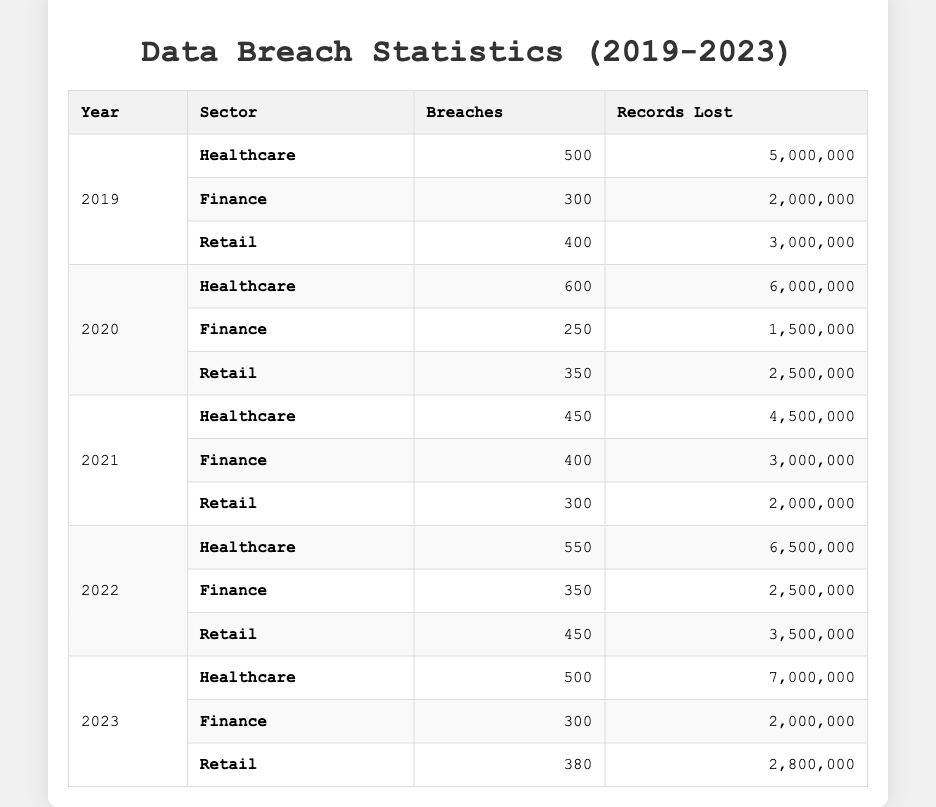What sector had the highest number of data breaches in 2020? In 2020, the Healthcare sector had 600 breaches, while Finance had 250 and Retail had 350. Therefore, Healthcare had the highest number of breaches.
Answer: Healthcare What is the total number of records lost in the Finance sector from 2019 to 2023? The records lost in Finance are: 2,000,000 (2019) + 1,500,000 (2020) + 3,000,000 (2021) + 2,500,000 (2022) + 2,000,000 (2023) = 11,000,000.
Answer: 11,000,000 Did the number of breaches in the Healthcare sector increase or decrease from 2019 to 2023? In 2019, there were 500 breaches, and in 2023, there were 500 breaches as well. Therefore, the number of breaches did not change (it stayed the same).
Answer: No change Which year had the most total breaches across all sectors? The total breaches for each year are: 2019: 500 + 300 + 400 = 1200; 2020: 600 + 250 + 350 = 1200; 2021: 450 + 400 + 300 = 1150; 2022: 550 + 350 + 450 = 1350; 2023: 500 + 300 + 380 = 1180. The highest was in 2022, with 1350 breaches.
Answer: 2022 What is the average number of breaches per year in the Retail sector over the five years? The breaches for Retail are: 400 (2019) + 350 (2020) + 300 (2021) + 450 (2022) + 380 (2023) = 1880. Dividing this by 5 gives 1880 / 5 = 376.
Answer: 376 Was there a year when the total number of records lost in the Retail sector exceeded those in the Healthcare sector? The records lost in Retail over the years: 3,000,000 (2019), 2,500,000 (2020), 2,000,000 (2021), 3,500,000 (2022), and 2,800,000 (2023). In Healthcare: 5,000,000 (2019), 6,000,000 (2020), 4,500,000 (2021), 6,500,000 (2022), 7,000,000 (2023) are consistently higher. Therefore, no year had more in Retail than in Healthcare.
Answer: No What is the percentage increase in data breaches for Healthcare from 2021 to 2022? The breaches in Healthcare were 450 in 2021 and 550 in 2022. The increase is 550 - 450 = 100. The percentage increase is (100 / 450) * 100 = 22.22%.
Answer: 22.22% How many records were lost in the Retail sector in 2021? In 2021, the Retail sector lost 2,000,000 records according to the table.
Answer: 2,000,000 Which sector had the lowest number of records lost in 2023? In 2023, the Finance sector lost 2,000,000 records, which is less than Healthcare (7,000,000) and Retail (2,800,000). Therefore, Finance had the lowest records lost.
Answer: Finance How many more breaches occurred in the Healthcare sector than in the Finance sector in 2022? In 2022, Healthcare had 550 breaches and Finance had 350 breaches. The difference is 550 - 350 = 200 breaches.
Answer: 200 